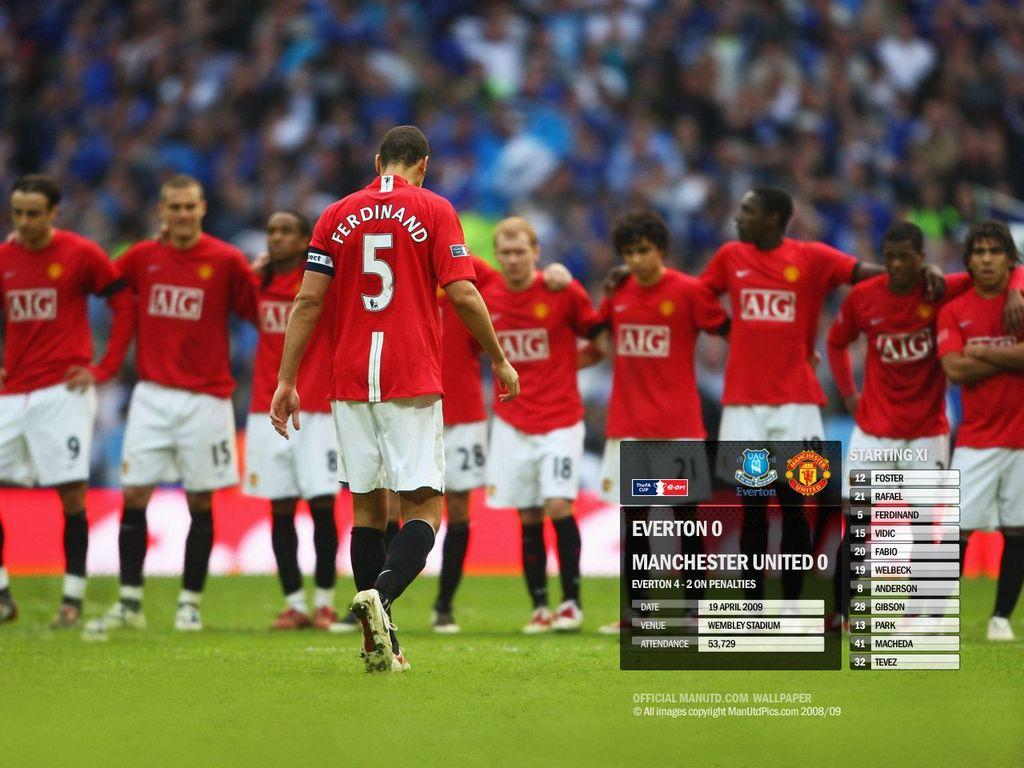<image>
Create a compact narrative representing the image presented. Player number 5, Ferdinand, walks towards his teammates who are standing in a line. 